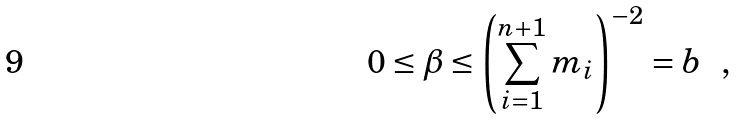Convert formula to latex. <formula><loc_0><loc_0><loc_500><loc_500>0 \leq \beta \leq \left ( \sum _ { i = 1 } ^ { n + 1 } m _ { i } \right ) ^ { - 2 } = b \ \ ,</formula> 